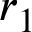<formula> <loc_0><loc_0><loc_500><loc_500>r _ { 1 }</formula> 